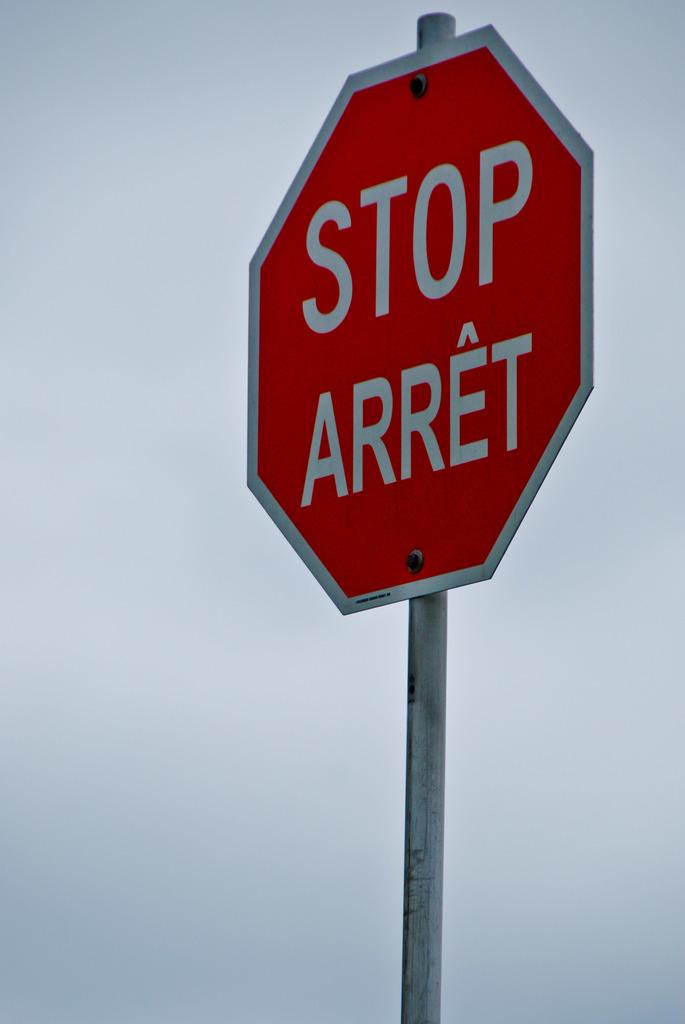What type of sign is this?
Offer a terse response. Stop. 